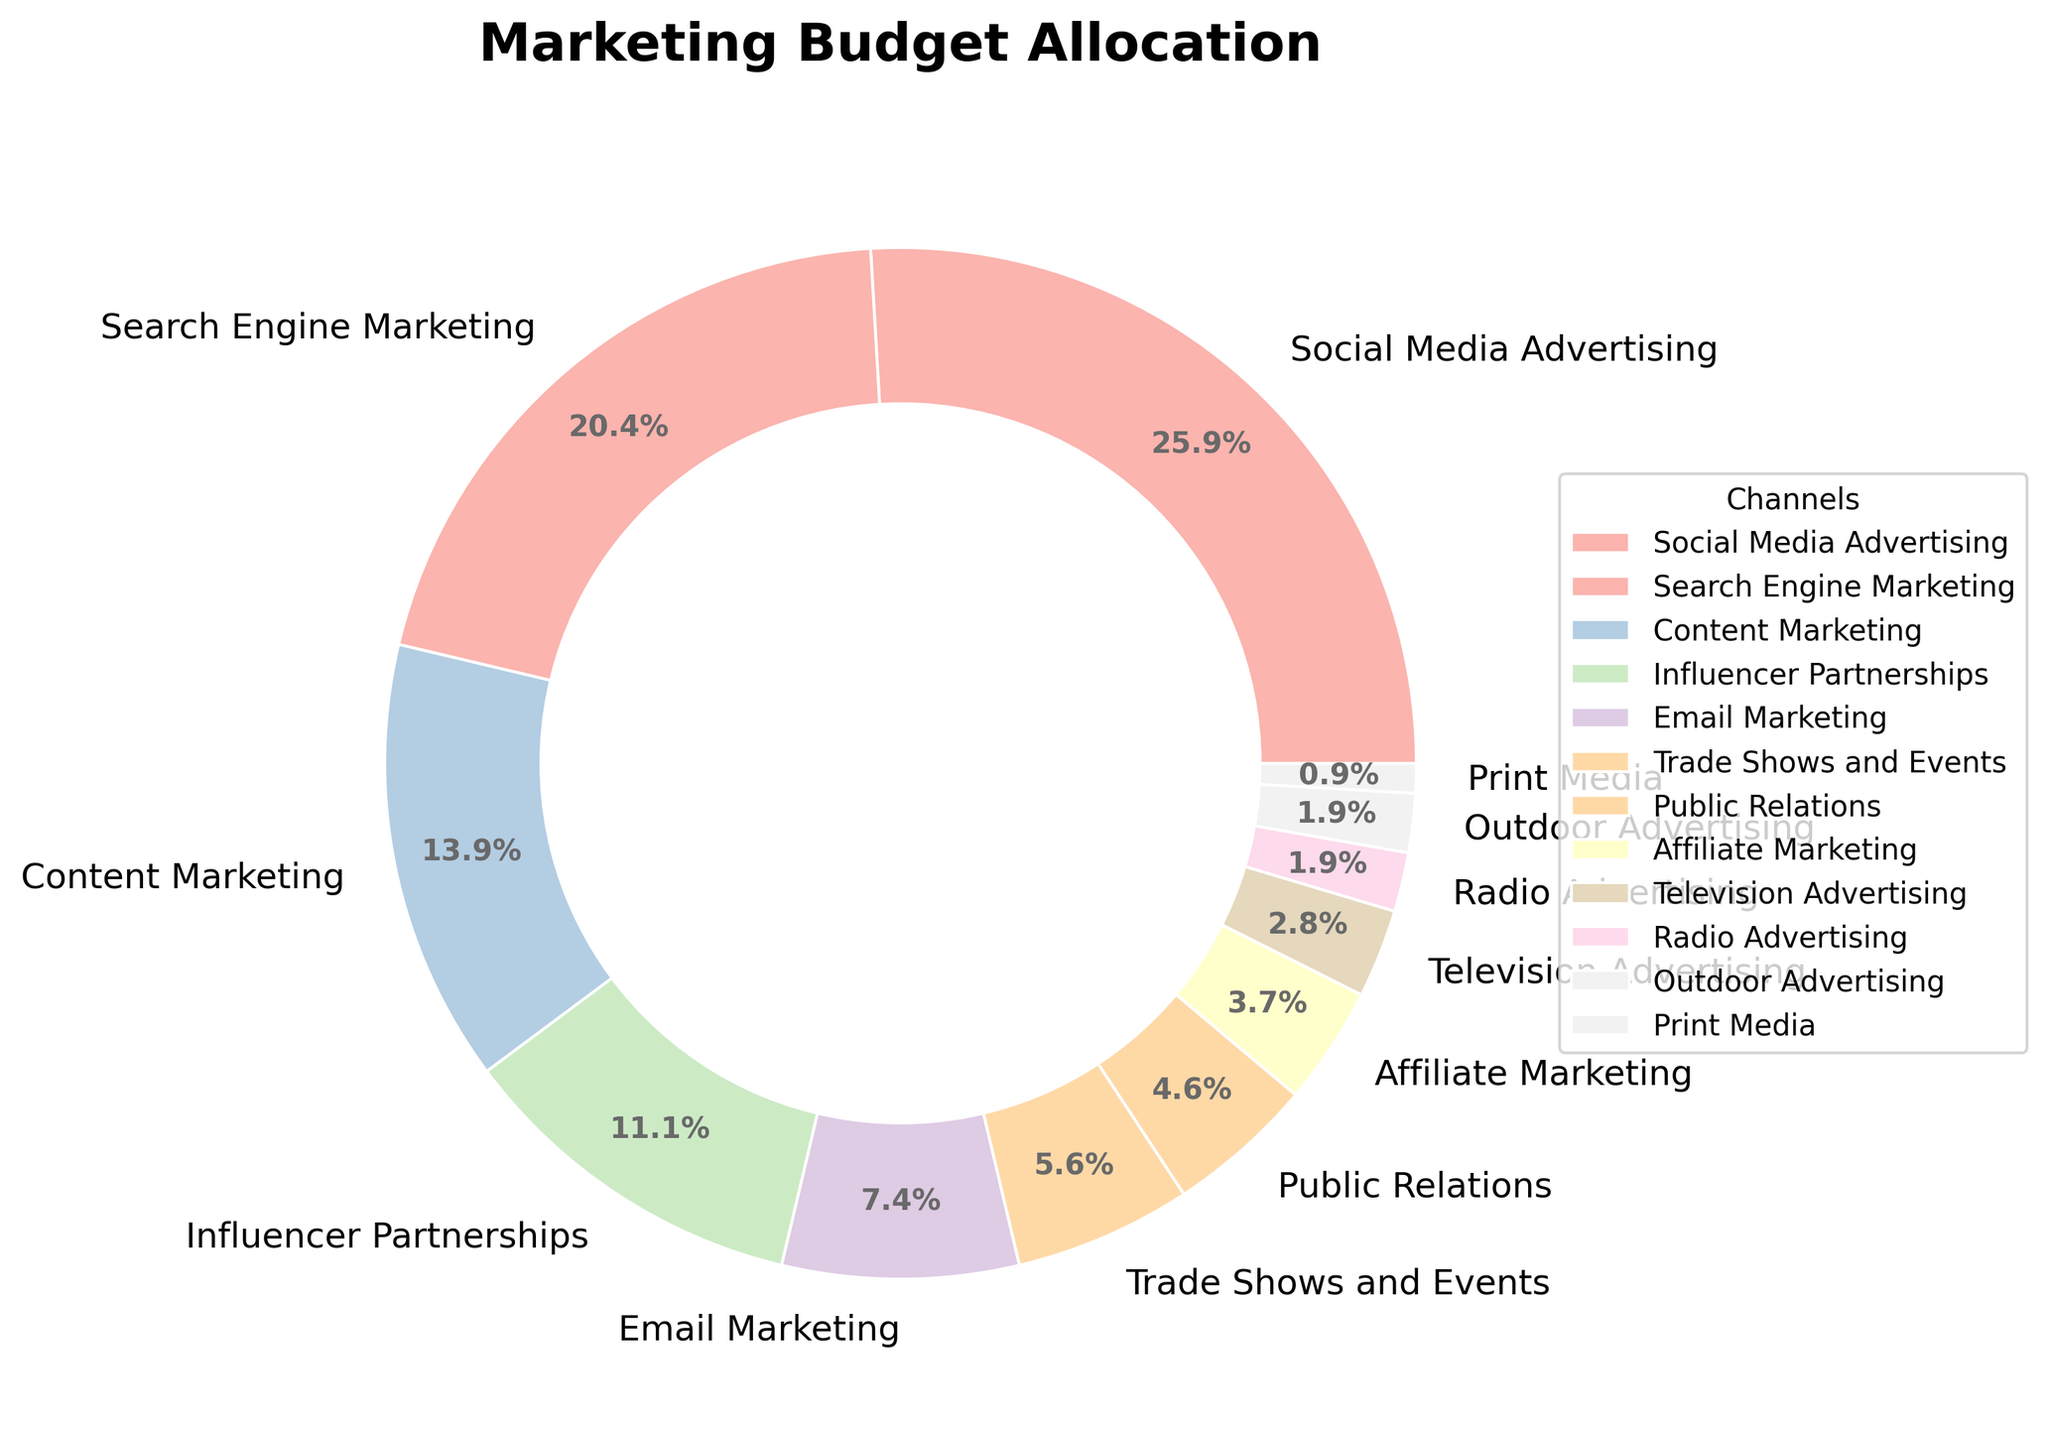Which channel gets the largest portion of the marketing budget? The largest portion is represented by the biggest wedge in the pie chart.
Answer: Social Media Advertising Which channel gets the least portion of the marketing budget? The smallest portion is represented by the smallest wedge in the pie chart.
Answer: Print Media What is the difference in percentage points between Social Media Advertising and Search Engine Marketing? Social Media Advertising has 28% and Search Engine Marketing has 22%. The difference is 28% - 22%.
Answer: 6% How many channels have a budget allocation of less than 5%? Channels that have wedge labels less than 5% are: Public Relations (5%), Affiliate Marketing (4%), Television Advertising (3%), Radio Advertising (2%), Outdoor Advertising (2%), and Print Media (1%).
Answer: 6 What is the total percentage allocated to Content Marketing, Influencer Partnerships, and Email Marketing? Content Marketing gets 15%, Influencer Partnerships get 12%, and Email Marketing gets 8%. Their sum is 15% + 12% + 8%.
Answer: 35% Is the allocation for Outdoor Advertising and Radio Advertising together more than that for Email Marketing? Outdoor Advertising has 2% and Radio Advertising also has 2%. Together, they total 2% + 2% = 4%, while Email Marketing has 8%. 4% < 8%.
Answer: No Which channels have equal budget allocations? Radio Advertising (2%) and Outdoor Advertising (2%) have equal allocations.
Answer: Radio Advertising and Outdoor Advertising How does the allocation for Trade Shows and Events compare to that for Affiliate Marketing? Trade Shows and Events have 6%, while Affiliate Marketing has 4%. Therefore, Trade Shows and Events have a higher allocation.
Answer: Trade Shows and Events What is the ratio of the budget allocation between Search Engine Marketing and Public Relations? Search Engine Marketing has 22% and Public Relations has 5%. The ratio is 22:5, which simplifies to 4.4:1.
Answer: 4.4:1 Which channel has approximately half the budget allocation of Social Media Advertising? Social Media Advertising is 28%. Influencer Partnerships are 12%, which is approximately half (28% / 2 = 14%).
Answer: Influencer Partnerships 